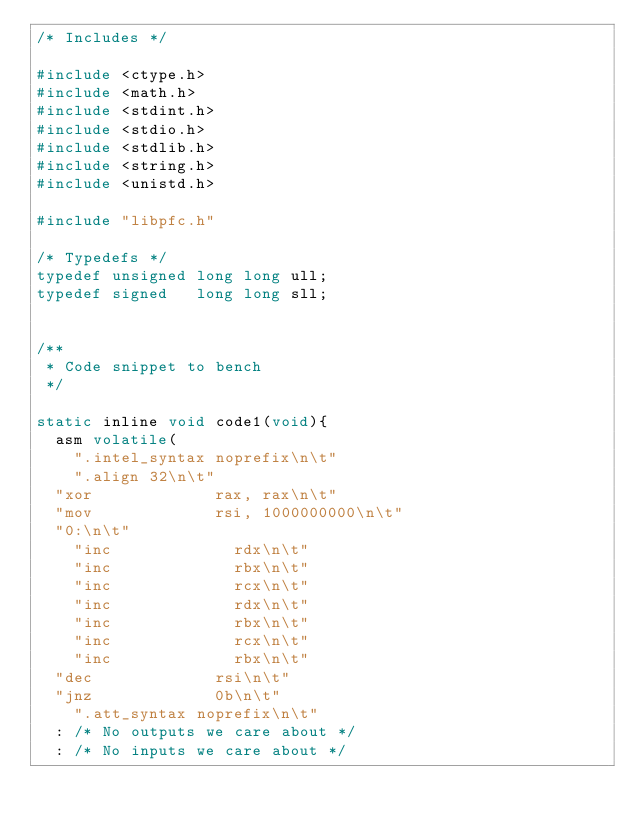<code> <loc_0><loc_0><loc_500><loc_500><_C_>/* Includes */

#include <ctype.h>
#include <math.h>
#include <stdint.h>
#include <stdio.h>
#include <stdlib.h>
#include <string.h>
#include <unistd.h>

#include "libpfc.h"

/* Typedefs */
typedef unsigned long long ull;
typedef signed   long long sll;


/**
 * Code snippet to bench
 */

static inline void code1(void){
	asm volatile(
    ".intel_syntax noprefix\n\t"
    ".align 32\n\t"
	"xor             rax, rax\n\t"
	"mov             rsi, 1000000000\n\t"
	"0:\n\t"
    "inc             rdx\n\t"
    "inc             rbx\n\t"
    "inc             rcx\n\t"
    "inc             rdx\n\t"
    "inc             rbx\n\t"
    "inc             rcx\n\t"
    "inc             rbx\n\t"
	"dec             rsi\n\t"
	"jnz             0b\n\t"
    ".att_syntax noprefix\n\t"
	: /* No outputs we care about */
	: /* No inputs we care about */</code> 